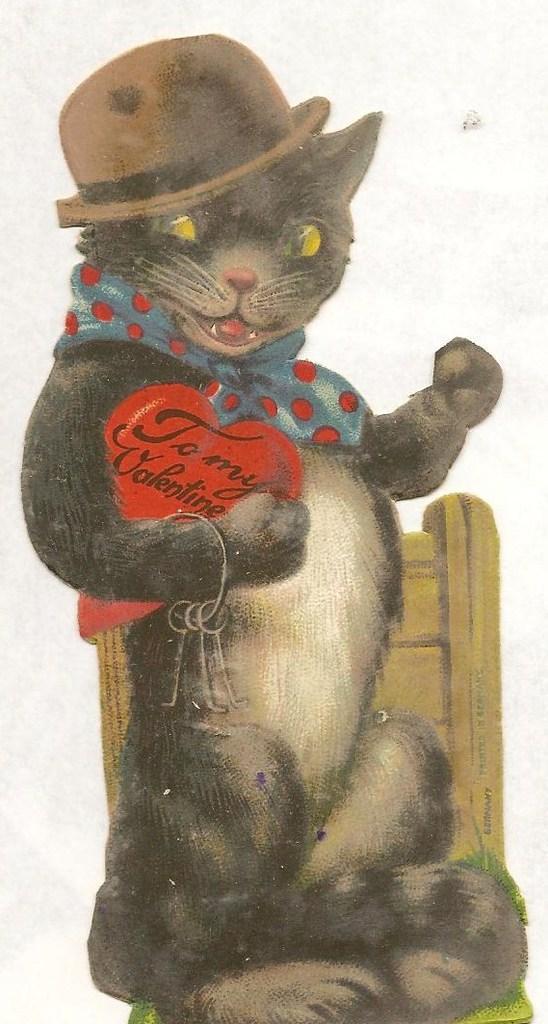In one or two sentences, can you explain what this image depicts? This is a painting. Here we can see a cat sitting on a chair by holding a card in the hand and carrying a bunch of keys on the hand and there is a hat and cloth on the head and the neck respectively. 